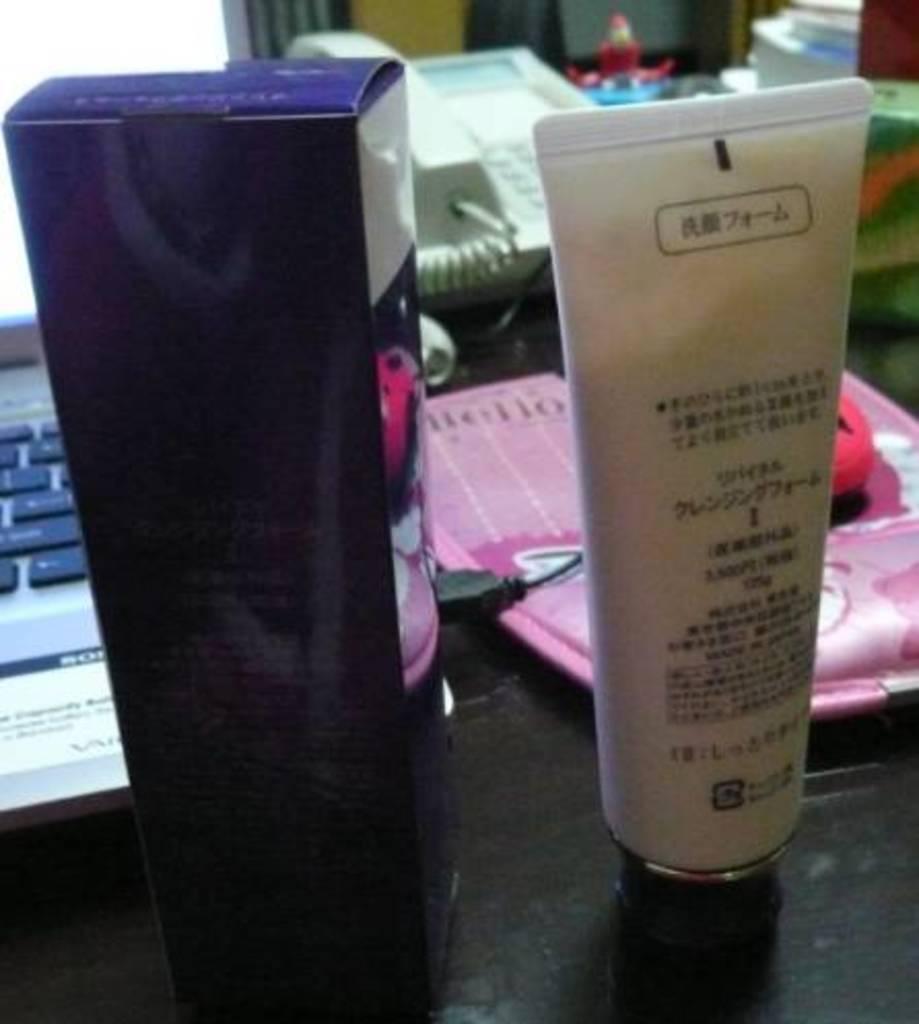Could you give a brief overview of what you see in this image? In this image there is a laptop towards the left of the image, there is a table towards the bottom of the image, there are objects on the table, there is a telephone on the table, there is a wire. 